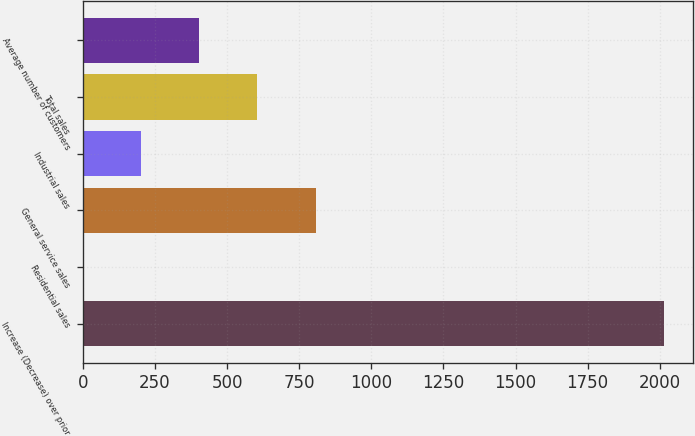Convert chart. <chart><loc_0><loc_0><loc_500><loc_500><bar_chart><fcel>Increase (Decrease) over prior<fcel>Residential sales<fcel>General service sales<fcel>Industrial sales<fcel>Total sales<fcel>Average number of customers<nl><fcel>2016<fcel>0.7<fcel>806.82<fcel>202.23<fcel>605.29<fcel>403.76<nl></chart> 